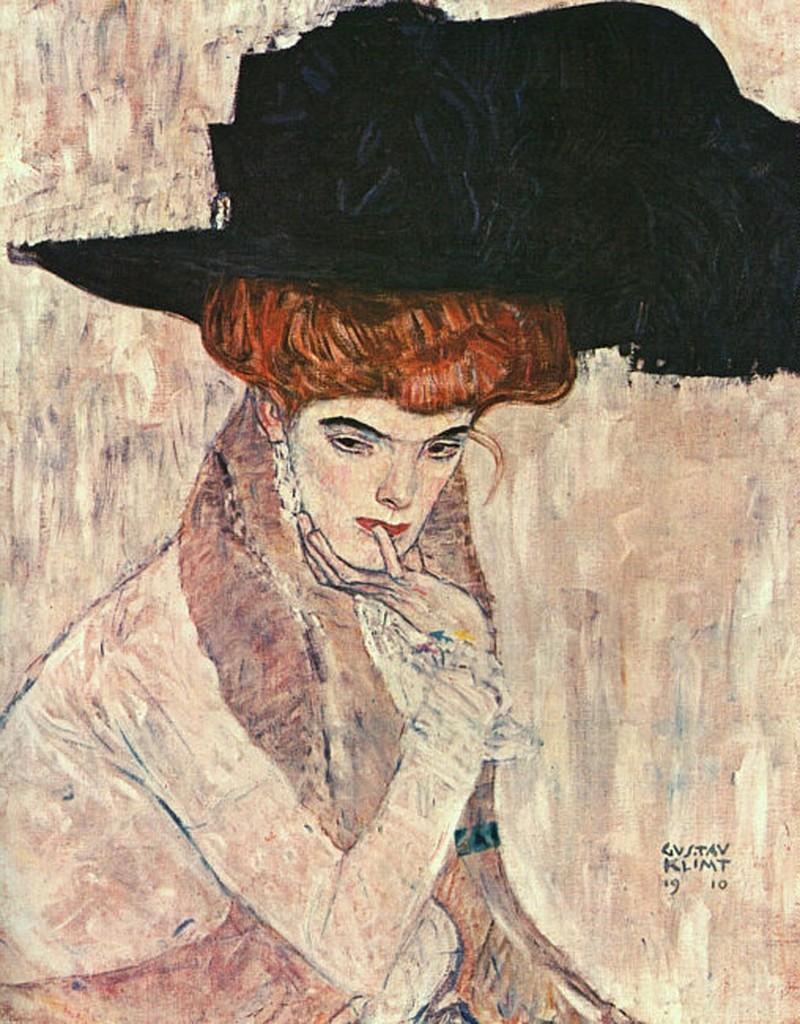How would you summarize this image in a sentence or two? This is a painting picture,in this painting we can see a person. 